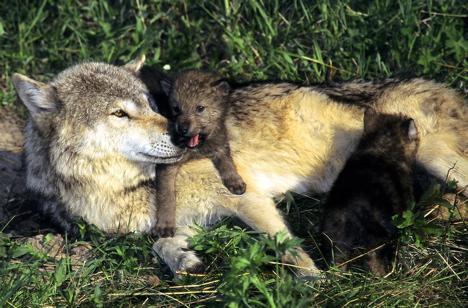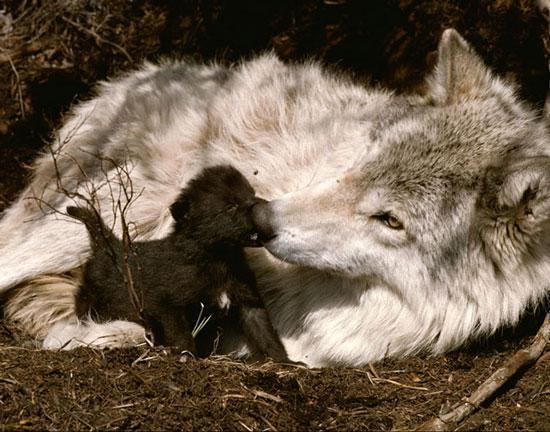The first image is the image on the left, the second image is the image on the right. Considering the images on both sides, is "Several pups are nursing in the image on the left." valid? Answer yes or no. No. The first image is the image on the left, the second image is the image on the right. Considering the images on both sides, is "One image shows no adult wolves, and the other image shows a standing adult wolf with multiple pups." valid? Answer yes or no. No. 